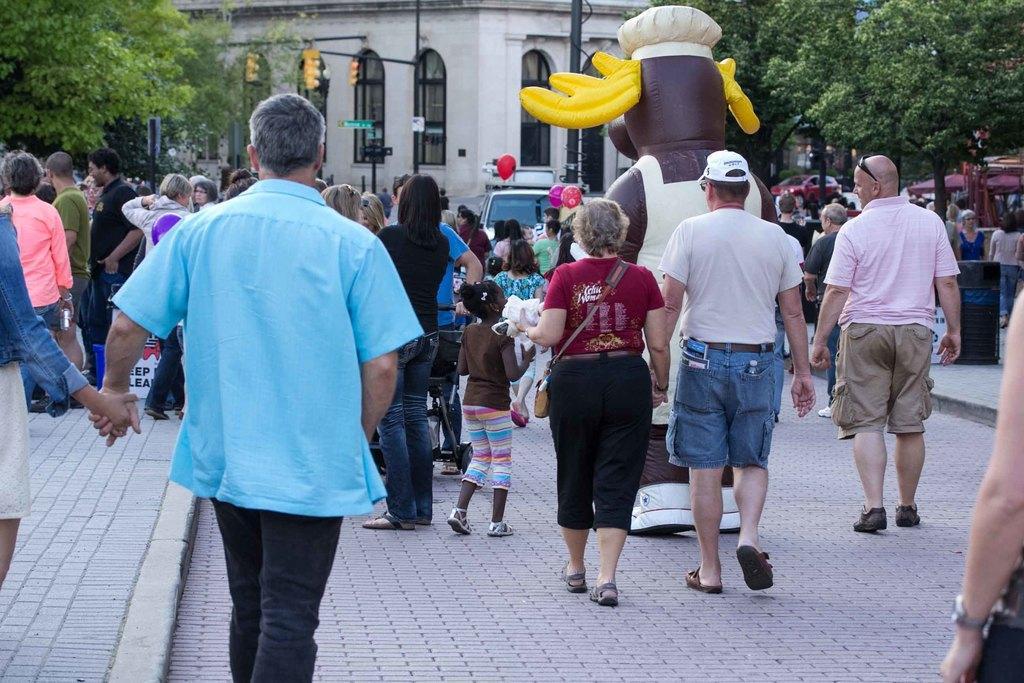Can you describe this image briefly? In this image there is a building towards the top of the image, there are windows, there are poles, there are traffic lights, there are trees towards the right of the image, there are trees towards the left of the image, there are vehicles, there is ground towards the bottom of the image, there are a group of persons, there are persons holding an object, there are objects towards the left of the image. 